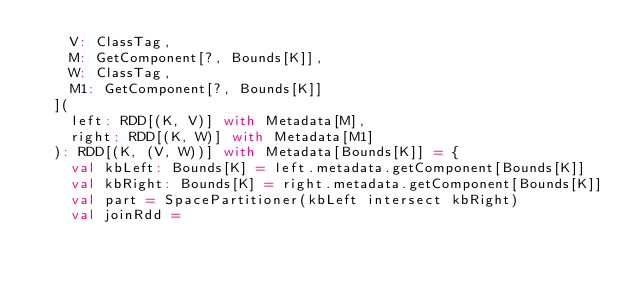Convert code to text. <code><loc_0><loc_0><loc_500><loc_500><_Scala_>    V: ClassTag,
    M: GetComponent[?, Bounds[K]],
    W: ClassTag,
    M1: GetComponent[?, Bounds[K]]
  ](
    left: RDD[(K, V)] with Metadata[M],
    right: RDD[(K, W)] with Metadata[M1]
  ): RDD[(K, (V, W))] with Metadata[Bounds[K]] = {
    val kbLeft: Bounds[K] = left.metadata.getComponent[Bounds[K]]
    val kbRight: Bounds[K] = right.metadata.getComponent[Bounds[K]]
    val part = SpacePartitioner(kbLeft intersect kbRight)
    val joinRdd =</code> 